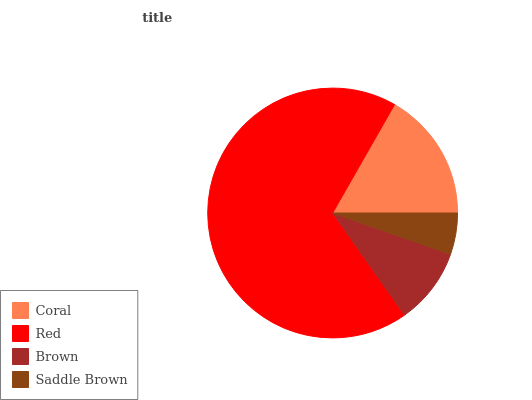Is Saddle Brown the minimum?
Answer yes or no. Yes. Is Red the maximum?
Answer yes or no. Yes. Is Brown the minimum?
Answer yes or no. No. Is Brown the maximum?
Answer yes or no. No. Is Red greater than Brown?
Answer yes or no. Yes. Is Brown less than Red?
Answer yes or no. Yes. Is Brown greater than Red?
Answer yes or no. No. Is Red less than Brown?
Answer yes or no. No. Is Coral the high median?
Answer yes or no. Yes. Is Brown the low median?
Answer yes or no. Yes. Is Red the high median?
Answer yes or no. No. Is Red the low median?
Answer yes or no. No. 